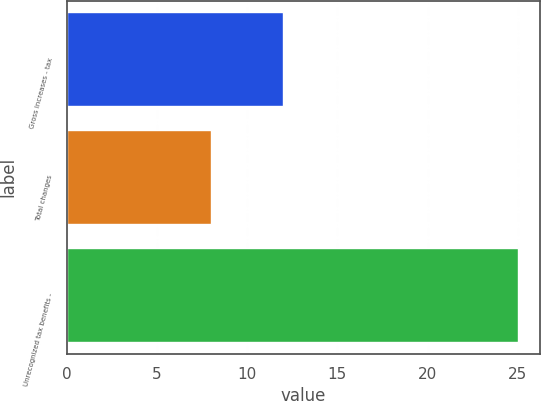Convert chart to OTSL. <chart><loc_0><loc_0><loc_500><loc_500><bar_chart><fcel>Gross increases - tax<fcel>Total changes<fcel>Unrecognized tax benefits -<nl><fcel>12<fcel>8<fcel>25<nl></chart> 